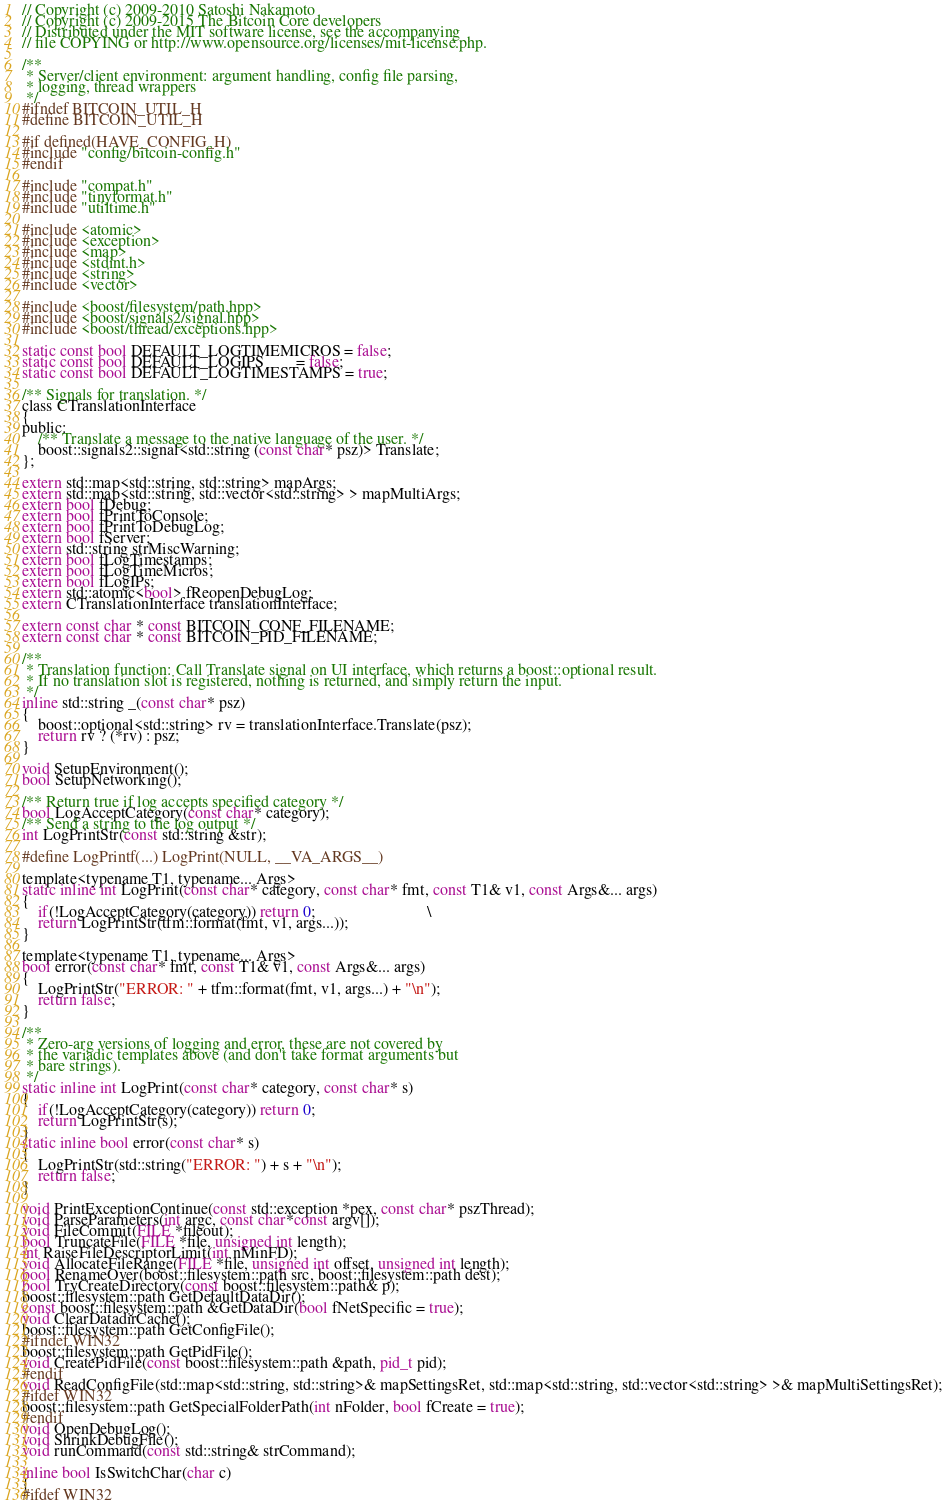<code> <loc_0><loc_0><loc_500><loc_500><_C_>// Copyright (c) 2009-2010 Satoshi Nakamoto
// Copyright (c) 2009-2015 The Bitcoin Core developers
// Distributed under the MIT software license, see the accompanying
// file COPYING or http://www.opensource.org/licenses/mit-license.php.

/**
 * Server/client environment: argument handling, config file parsing,
 * logging, thread wrappers
 */
#ifndef BITCOIN_UTIL_H
#define BITCOIN_UTIL_H

#if defined(HAVE_CONFIG_H)
#include "config/bitcoin-config.h"
#endif

#include "compat.h"
#include "tinyformat.h"
#include "utiltime.h"

#include <atomic>
#include <exception>
#include <map>
#include <stdint.h>
#include <string>
#include <vector>

#include <boost/filesystem/path.hpp>
#include <boost/signals2/signal.hpp>
#include <boost/thread/exceptions.hpp>

static const bool DEFAULT_LOGTIMEMICROS = false;
static const bool DEFAULT_LOGIPS        = false;
static const bool DEFAULT_LOGTIMESTAMPS = true;

/** Signals for translation. */
class CTranslationInterface
{
public:
    /** Translate a message to the native language of the user. */
    boost::signals2::signal<std::string (const char* psz)> Translate;
};

extern std::map<std::string, std::string> mapArgs;
extern std::map<std::string, std::vector<std::string> > mapMultiArgs;
extern bool fDebug;
extern bool fPrintToConsole;
extern bool fPrintToDebugLog;
extern bool fServer;
extern std::string strMiscWarning;
extern bool fLogTimestamps;
extern bool fLogTimeMicros;
extern bool fLogIPs;
extern std::atomic<bool> fReopenDebugLog;
extern CTranslationInterface translationInterface;

extern const char * const BITCOIN_CONF_FILENAME;
extern const char * const BITCOIN_PID_FILENAME;

/**
 * Translation function: Call Translate signal on UI interface, which returns a boost::optional result.
 * If no translation slot is registered, nothing is returned, and simply return the input.
 */
inline std::string _(const char* psz)
{
    boost::optional<std::string> rv = translationInterface.Translate(psz);
    return rv ? (*rv) : psz;
}

void SetupEnvironment();
bool SetupNetworking();

/** Return true if log accepts specified category */
bool LogAcceptCategory(const char* category);
/** Send a string to the log output */
int LogPrintStr(const std::string &str);

#define LogPrintf(...) LogPrint(NULL, __VA_ARGS__)

template<typename T1, typename... Args>
static inline int LogPrint(const char* category, const char* fmt, const T1& v1, const Args&... args)
{
    if(!LogAcceptCategory(category)) return 0;                            \
    return LogPrintStr(tfm::format(fmt, v1, args...));
}

template<typename T1, typename... Args>
bool error(const char* fmt, const T1& v1, const Args&... args)
{
    LogPrintStr("ERROR: " + tfm::format(fmt, v1, args...) + "\n");
    return false;
}

/**
 * Zero-arg versions of logging and error, these are not covered by
 * the variadic templates above (and don't take format arguments but
 * bare strings).
 */
static inline int LogPrint(const char* category, const char* s)
{
    if(!LogAcceptCategory(category)) return 0;
    return LogPrintStr(s);
}
static inline bool error(const char* s)
{
    LogPrintStr(std::string("ERROR: ") + s + "\n");
    return false;
}

void PrintExceptionContinue(const std::exception *pex, const char* pszThread);
void ParseParameters(int argc, const char*const argv[]);
void FileCommit(FILE *fileout);
bool TruncateFile(FILE *file, unsigned int length);
int RaiseFileDescriptorLimit(int nMinFD);
void AllocateFileRange(FILE *file, unsigned int offset, unsigned int length);
bool RenameOver(boost::filesystem::path src, boost::filesystem::path dest);
bool TryCreateDirectory(const boost::filesystem::path& p);
boost::filesystem::path GetDefaultDataDir();
const boost::filesystem::path &GetDataDir(bool fNetSpecific = true);
void ClearDatadirCache();
boost::filesystem::path GetConfigFile();
#ifndef WIN32
boost::filesystem::path GetPidFile();
void CreatePidFile(const boost::filesystem::path &path, pid_t pid);
#endif
void ReadConfigFile(std::map<std::string, std::string>& mapSettingsRet, std::map<std::string, std::vector<std::string> >& mapMultiSettingsRet);
#ifdef WIN32
boost::filesystem::path GetSpecialFolderPath(int nFolder, bool fCreate = true);
#endif
void OpenDebugLog();
void ShrinkDebugFile();
void runCommand(const std::string& strCommand);

inline bool IsSwitchChar(char c)
{
#ifdef WIN32</code> 